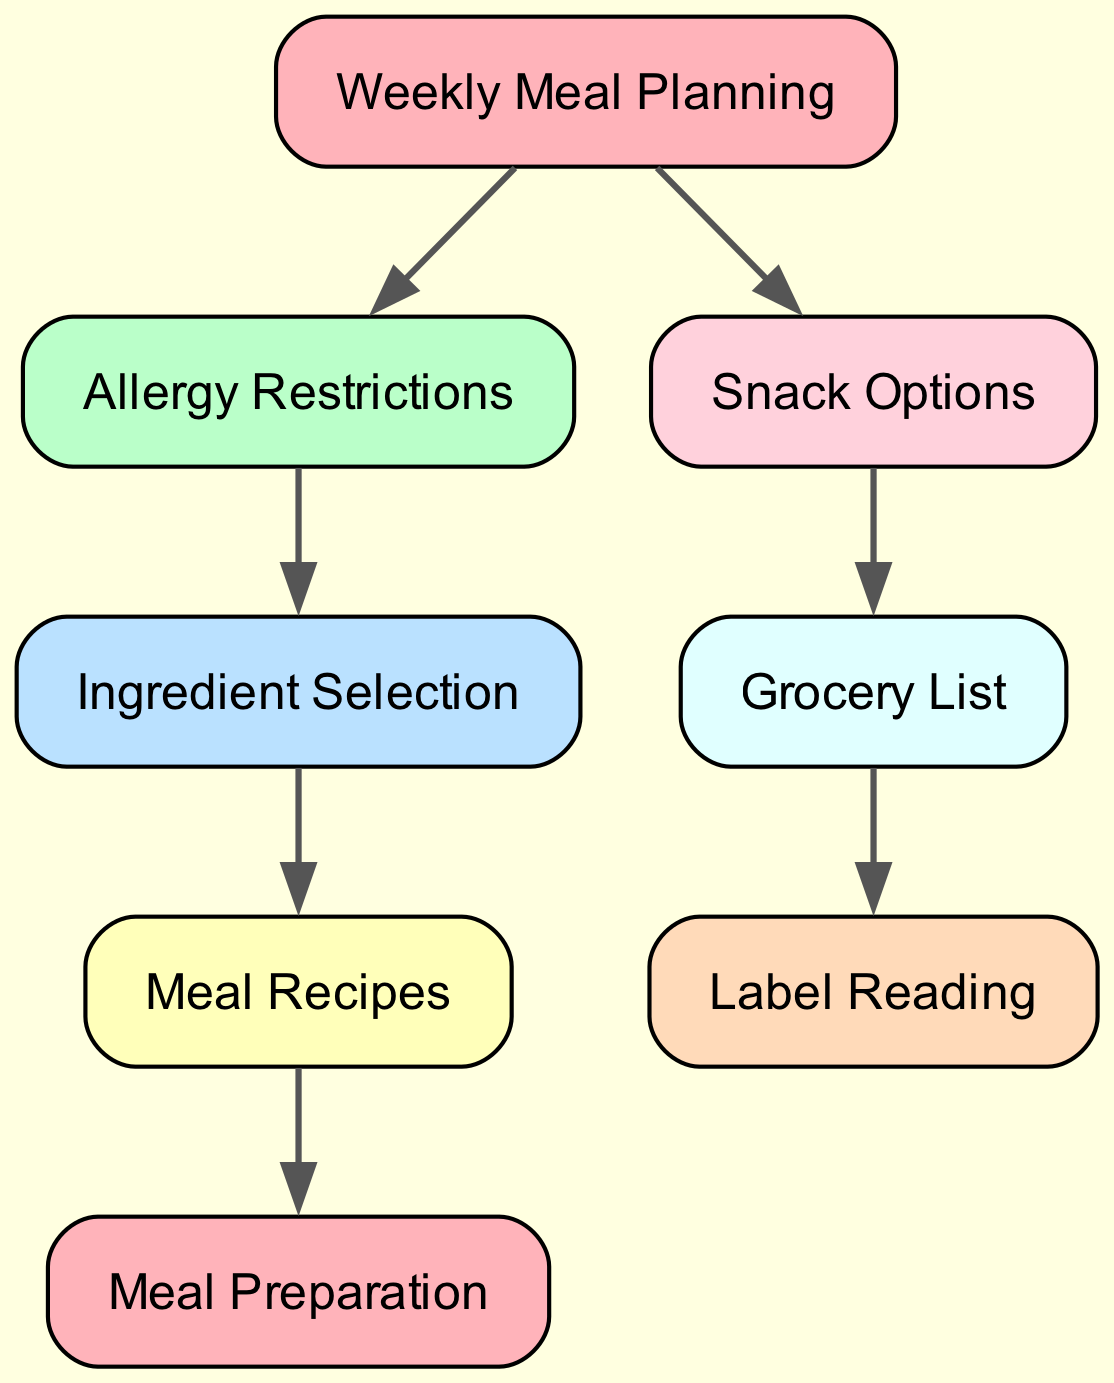What is the starting node of the directed graph? The directed graph begins with the node labeled "Weekly Meal Planning." This information can be identified as it has outgoing edges to other nodes, indicating it is the initiating point.
Answer: Weekly Meal Planning How many nodes are present in the diagram? By counting each unique node represented, we find there are eight nodes: Weekly Meal Planning, Allergy Restrictions, Ingredient Selection, Meal Recipes, Snack Options, Grocery List, Label Reading, and Meal Preparation.
Answer: Eight What connects Allergy Restrictions to Ingredient Selection? Looking at the edge relationships, there is a direct connection from the node "Allergy Restrictions" to the node "Ingredient Selection," indicating that Allergy Restrictions influence ingredient choices.
Answer: Ingredient Selection Which nodes depend on Meal Recipes? Tracing the arrows, we see that "Meal Preparation" is the only node that depends on "Meal Recipes," indicating that meal preparation follows meal recipe selection.
Answer: Meal Preparation What is the final step in the meal planning process? The directed graph points from the last actionable node, which is "Meal Preparation," thus indicating that this is the final step in the meal planning process. No further nodes follow this.
Answer: Meal Preparation How do Snack Options relate to Grocery List? There is a directed edge from "Snack Options" to "Grocery List," showing that the types of snack options selected directly affect what is included in the grocery list.
Answer: Grocery List How many edges are in the directed graph? By counting the directed relationships connecting the nodes, there are seven edges in total, representing the various connections between different steps in the meal planning process.
Answer: Seven What is the relationship between Ingredient Selection and Meal Recipes? The relationship is directional; "Ingredient Selection" leads to "Meal Recipes," meaning that the selection of ingredients is necessary prior to formulating the recipes for meals.
Answer: Meal Recipes 